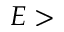Convert formula to latex. <formula><loc_0><loc_0><loc_500><loc_500>E ></formula> 